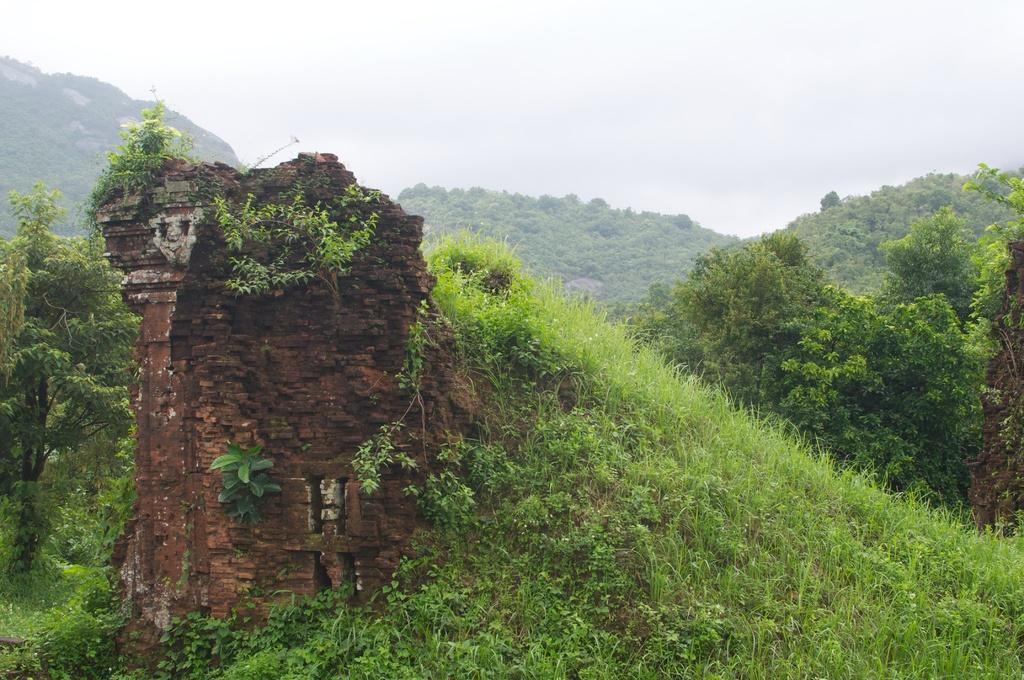Please provide a concise description of this image. In this image we can see trees, grass, hills, sky and clouds. 